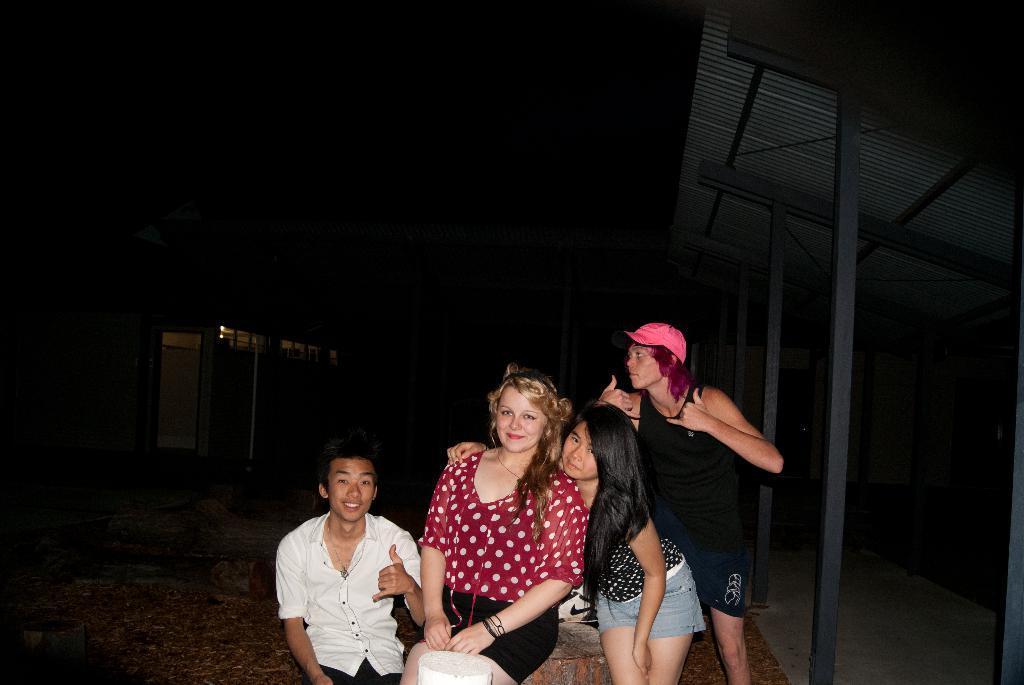In one or two sentences, can you explain what this image depicts? This picture shows couple of women and couple of men and we see e house on the back and we see a man standing and wore a cap on his head and we see a paper bag 